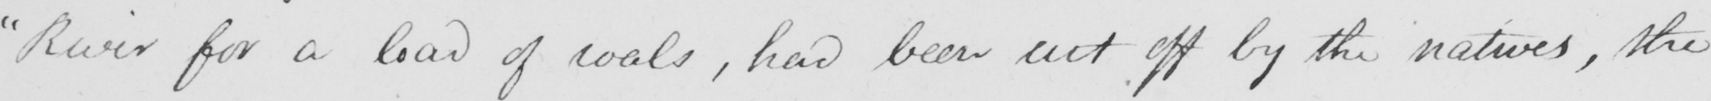What text is written in this handwritten line? " River for a load of coals , had been cut off by the natives , the 